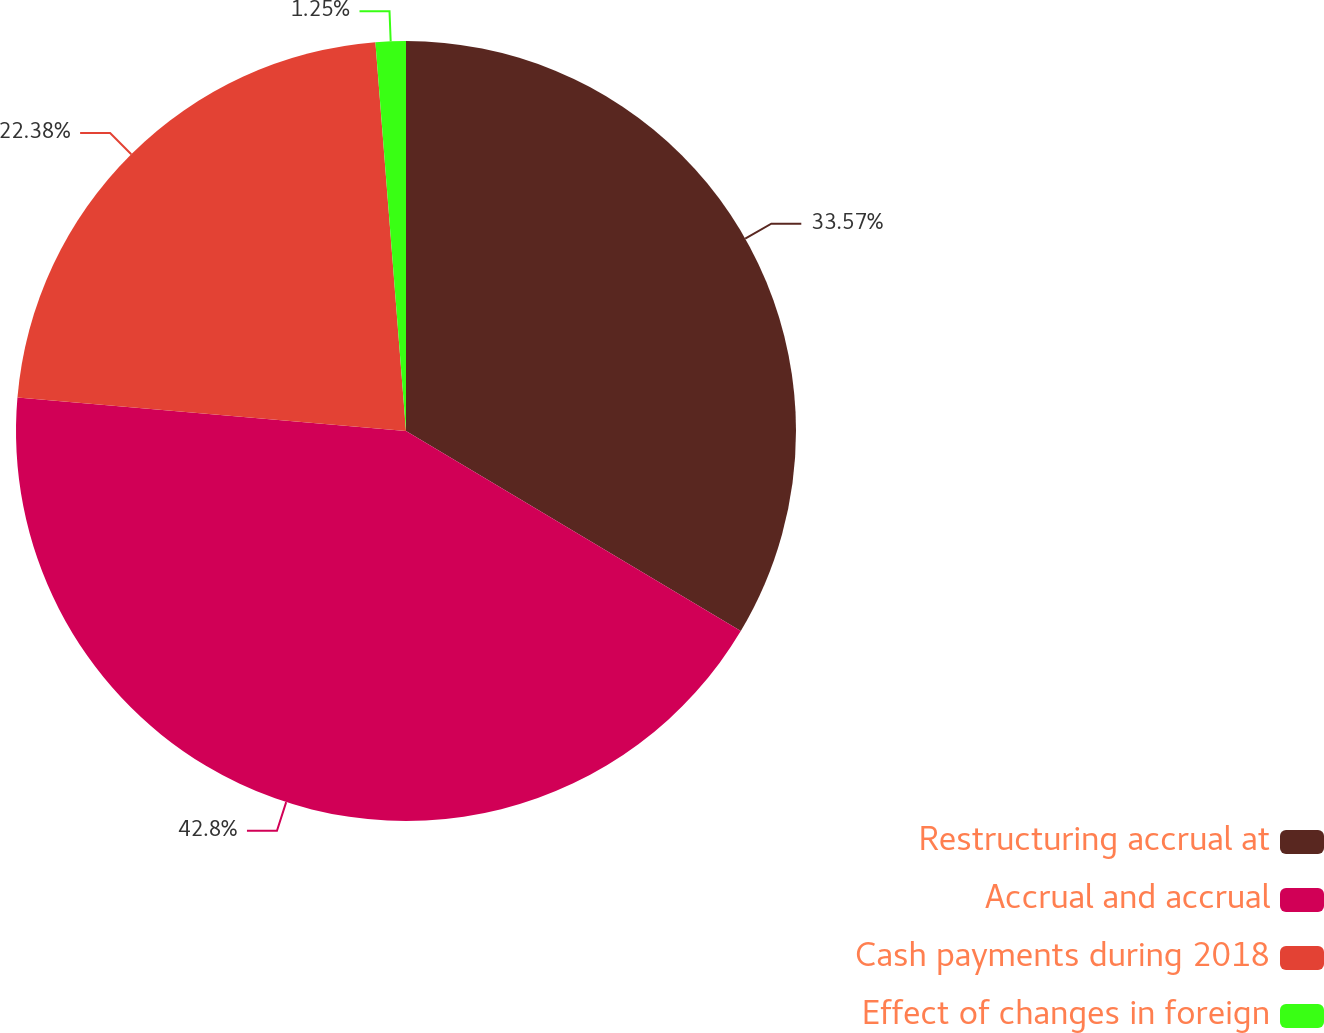<chart> <loc_0><loc_0><loc_500><loc_500><pie_chart><fcel>Restructuring accrual at<fcel>Accrual and accrual<fcel>Cash payments during 2018<fcel>Effect of changes in foreign<nl><fcel>33.57%<fcel>42.79%<fcel>22.38%<fcel>1.25%<nl></chart> 